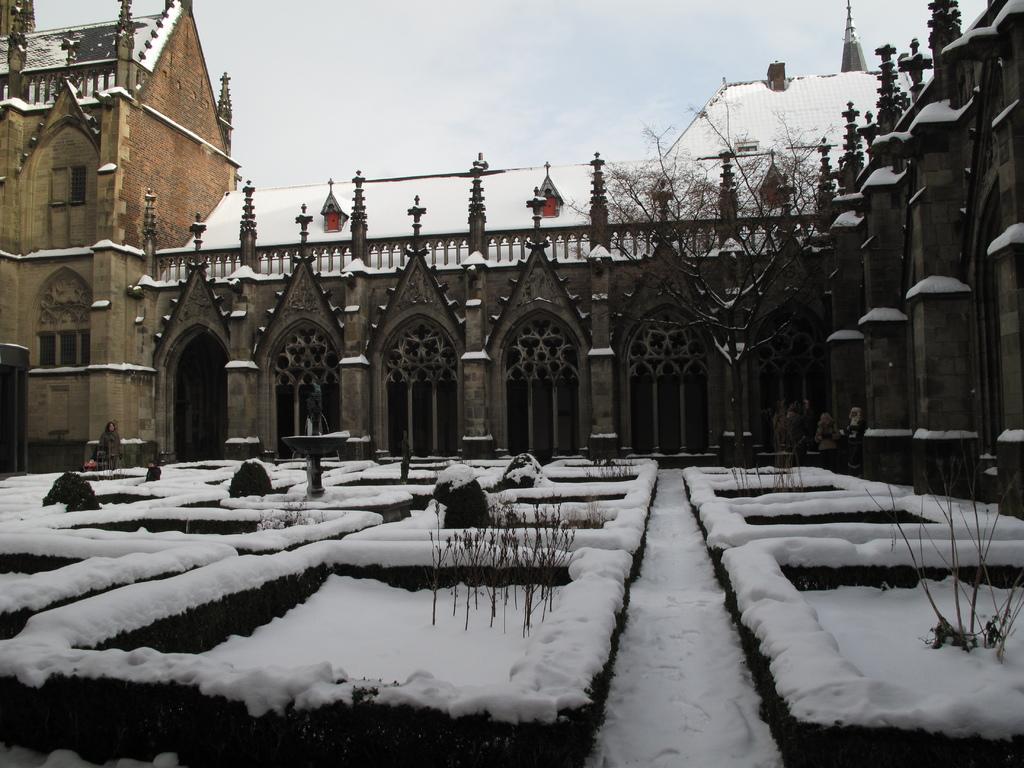Can you describe this image briefly? As we can see in the image there are buildings, snow, tree and on the top there is sky. 